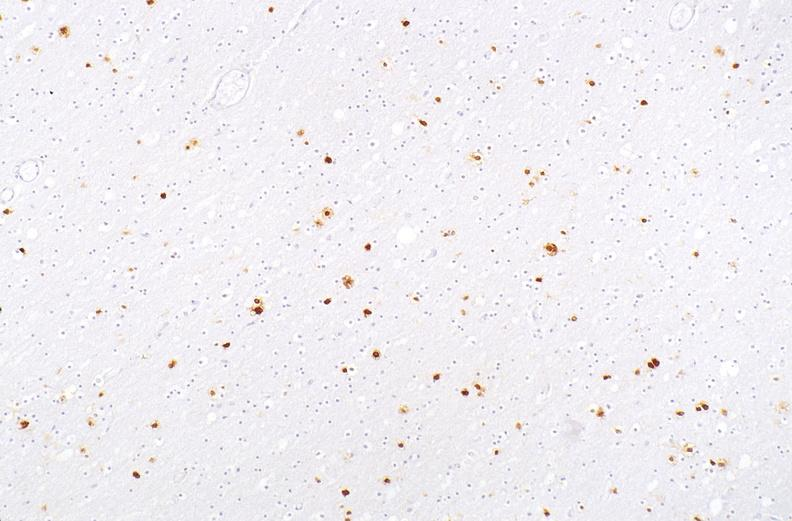s optic nerve present?
Answer the question using a single word or phrase. No 